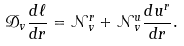<formula> <loc_0><loc_0><loc_500><loc_500>\mathcal { D } _ { v } \frac { d \ell } { d r } = \mathcal { N } _ { v } ^ { r } + \mathcal { N } _ { v } ^ { u } \frac { d u ^ { r } } { d r } .</formula> 